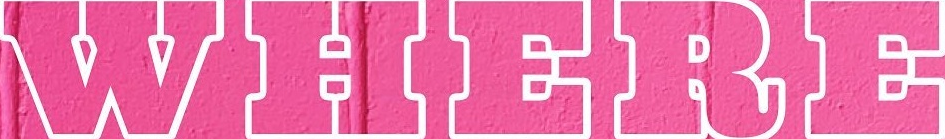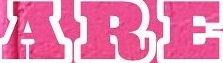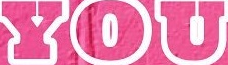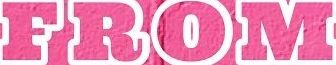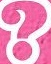What text appears in these images from left to right, separated by a semicolon? WHERE; ARE; YOU; FROM; ? 